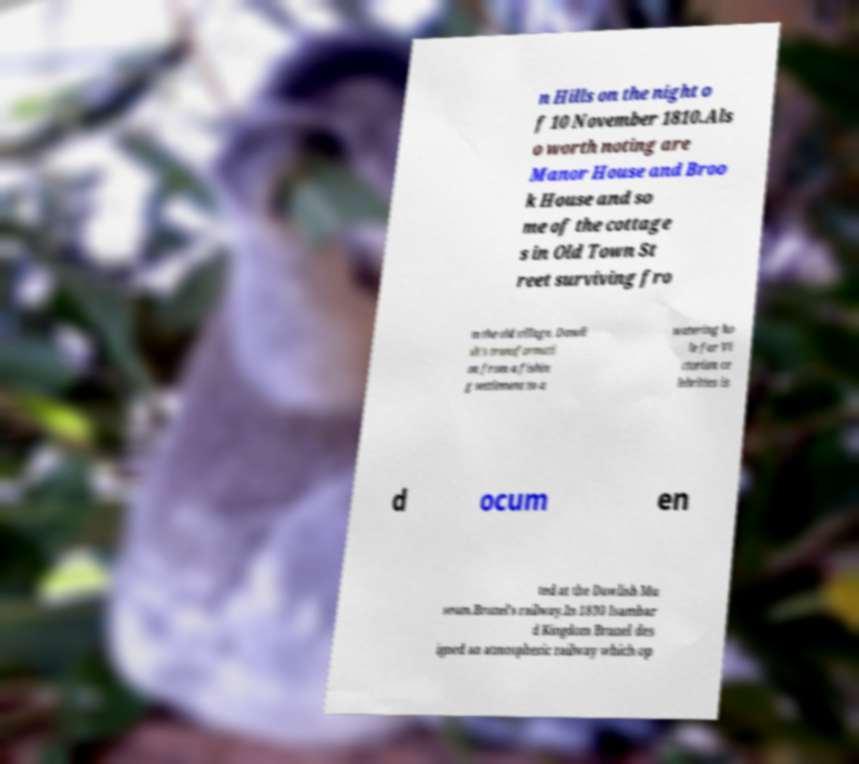There's text embedded in this image that I need extracted. Can you transcribe it verbatim? n Hills on the night o f 10 November 1810.Als o worth noting are Manor House and Broo k House and so me of the cottage s in Old Town St reet surviving fro m the old village. Dawli sh's transformati on from a fishin g settlement to a watering ho le for Vi ctorian ce lebrities is d ocum en ted at the Dawlish Mu seum.Brunel's railway.In 1830 Isambar d Kingdom Brunel des igned an atmospheric railway which op 